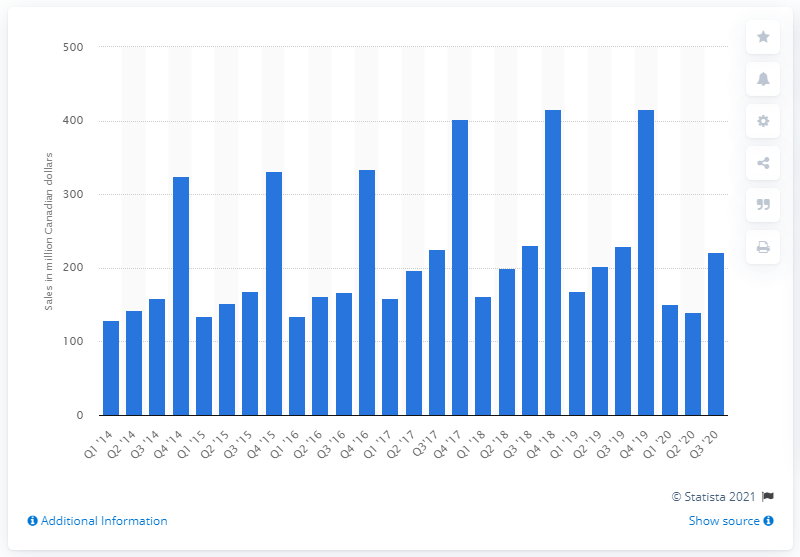List a handful of essential elements in this visual. In the third quarter of 2020, the total sales of men's underwear, sleepwear, and hosiery in Canada were 221.05. 